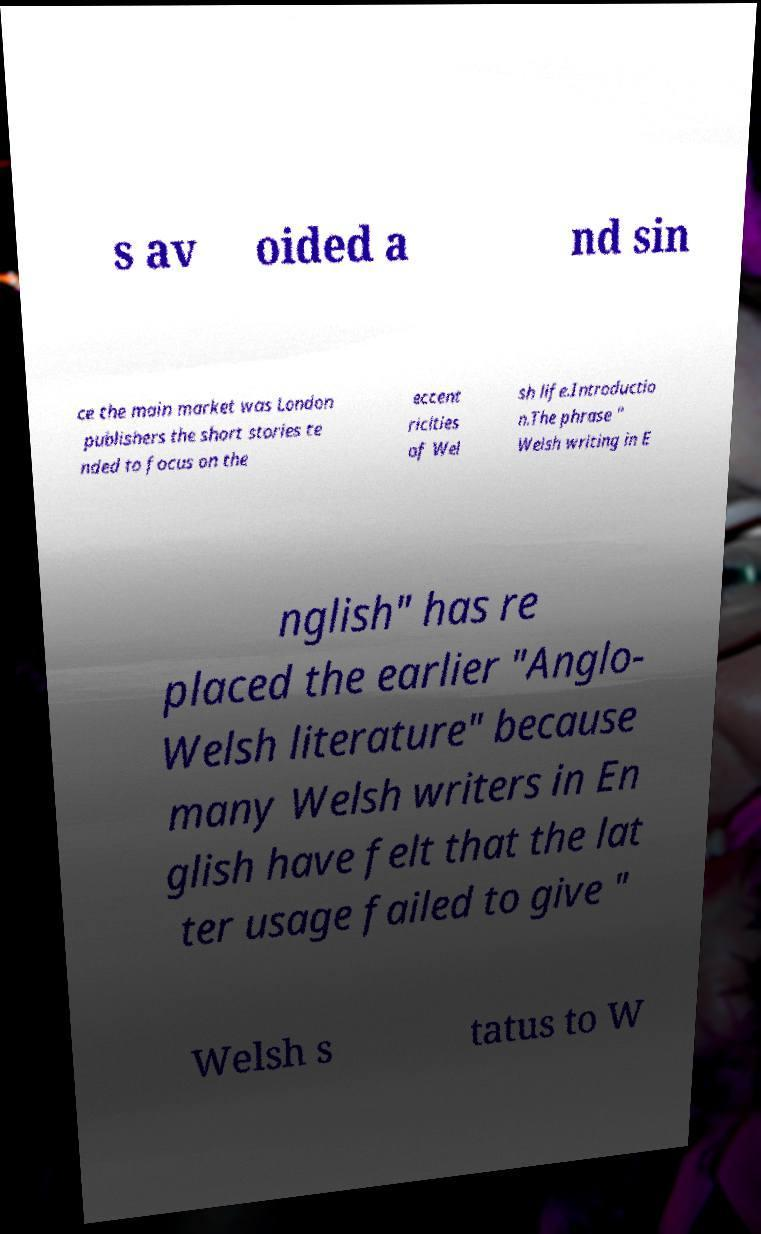I need the written content from this picture converted into text. Can you do that? s av oided a nd sin ce the main market was London publishers the short stories te nded to focus on the eccent ricities of Wel sh life.Introductio n.The phrase " Welsh writing in E nglish" has re placed the earlier "Anglo- Welsh literature" because many Welsh writers in En glish have felt that the lat ter usage failed to give " Welsh s tatus to W 